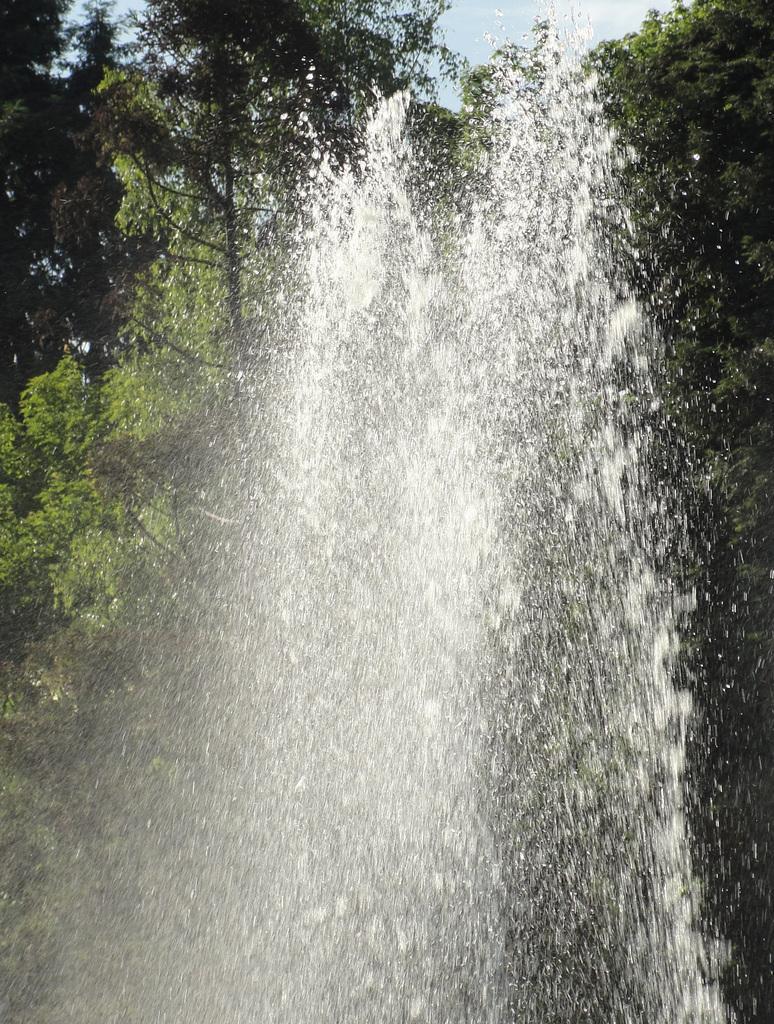Can you describe this image briefly? In the foreground of the picture there is water. In the background there are trees. It is sunny. 